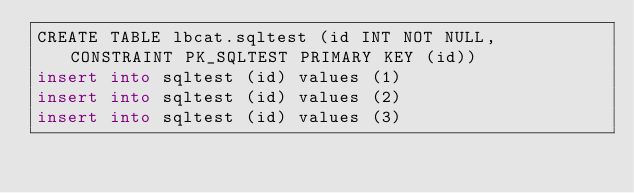Convert code to text. <code><loc_0><loc_0><loc_500><loc_500><_SQL_>CREATE TABLE lbcat.sqltest (id INT NOT NULL, CONSTRAINT PK_SQLTEST PRIMARY KEY (id))
insert into sqltest (id) values (1)
insert into sqltest (id) values (2)
insert into sqltest (id) values (3)

</code> 